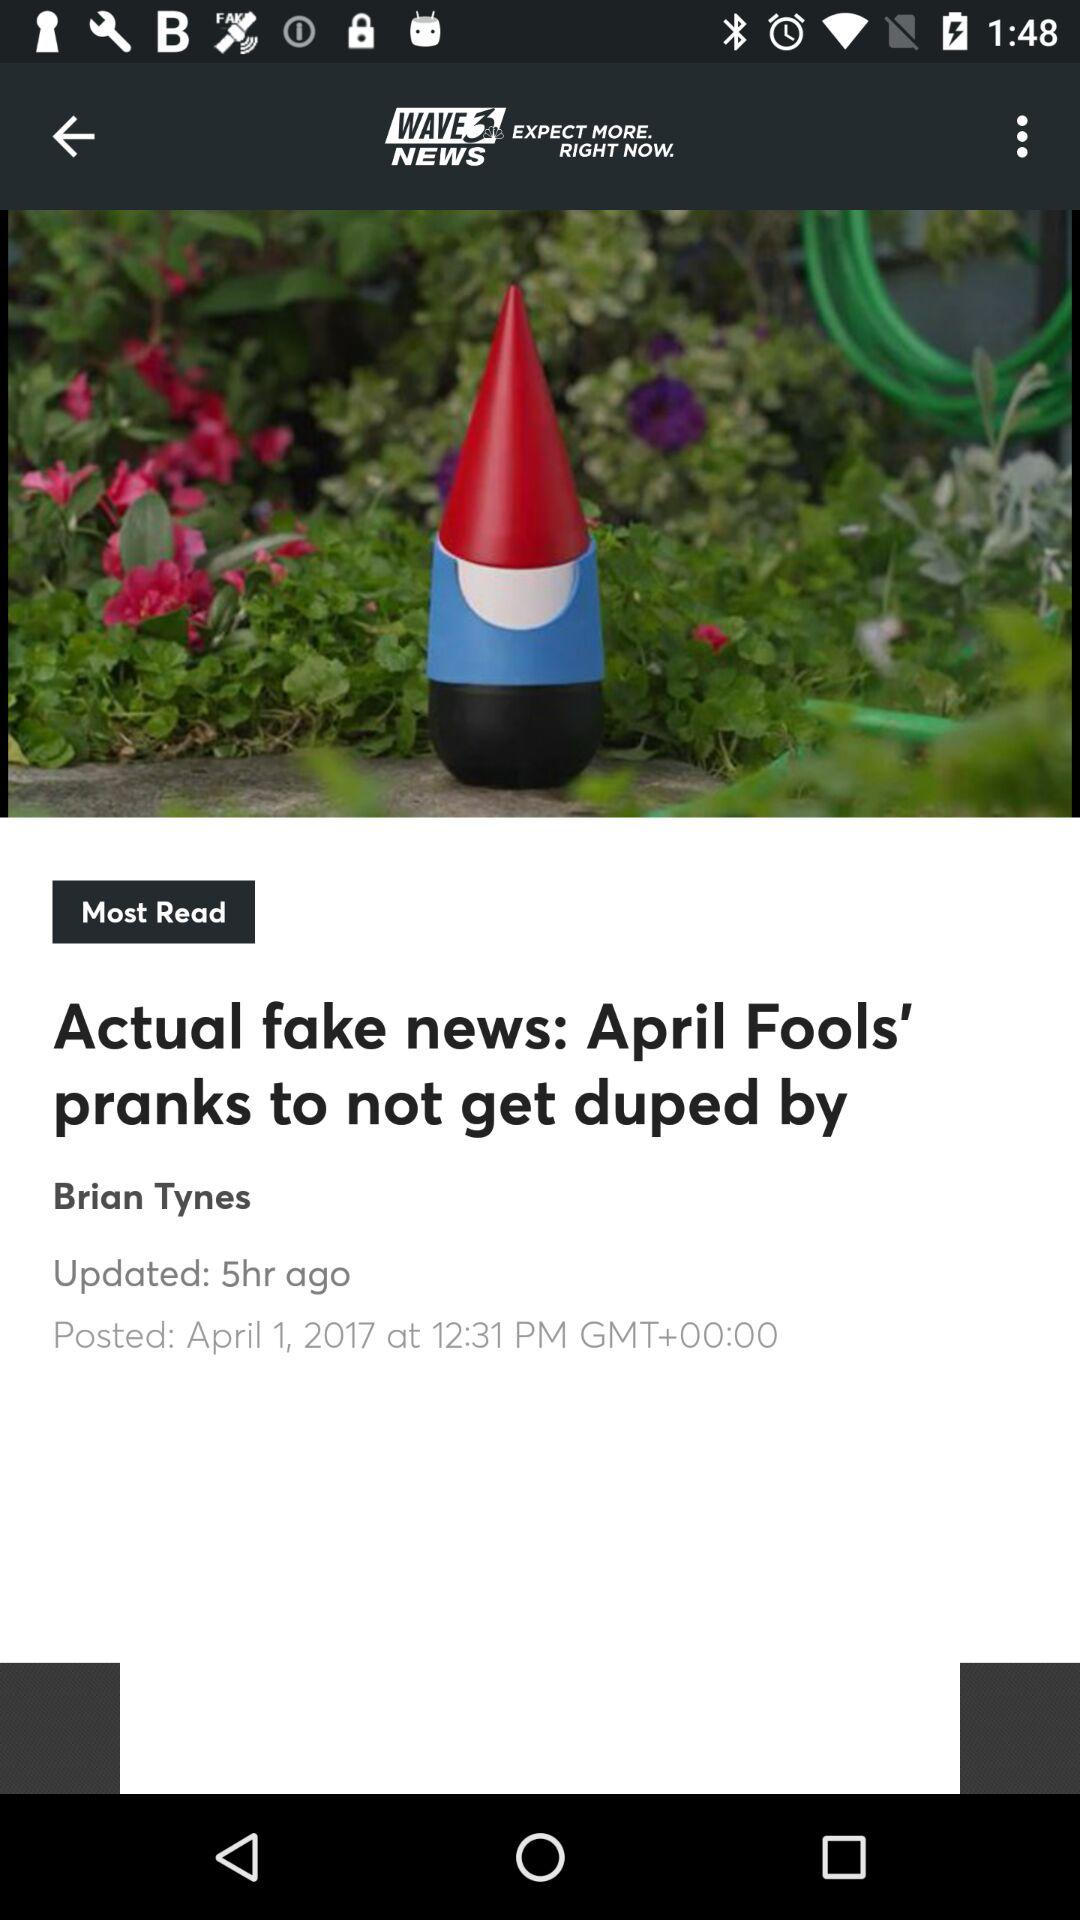Who is the author? The author is "Brian Tynes". 